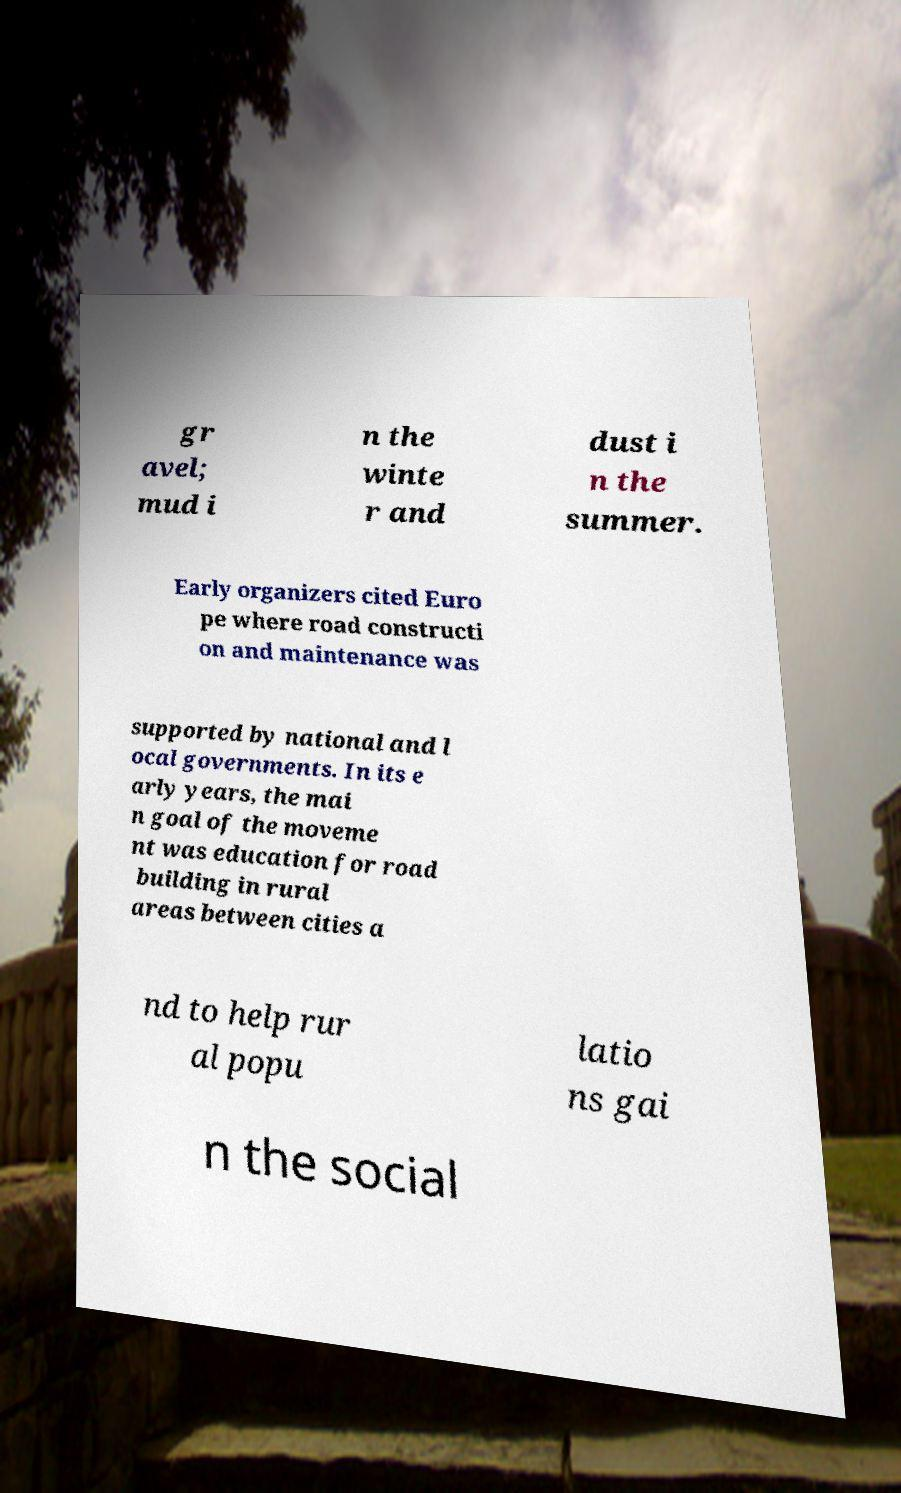Can you accurately transcribe the text from the provided image for me? gr avel; mud i n the winte r and dust i n the summer. Early organizers cited Euro pe where road constructi on and maintenance was supported by national and l ocal governments. In its e arly years, the mai n goal of the moveme nt was education for road building in rural areas between cities a nd to help rur al popu latio ns gai n the social 